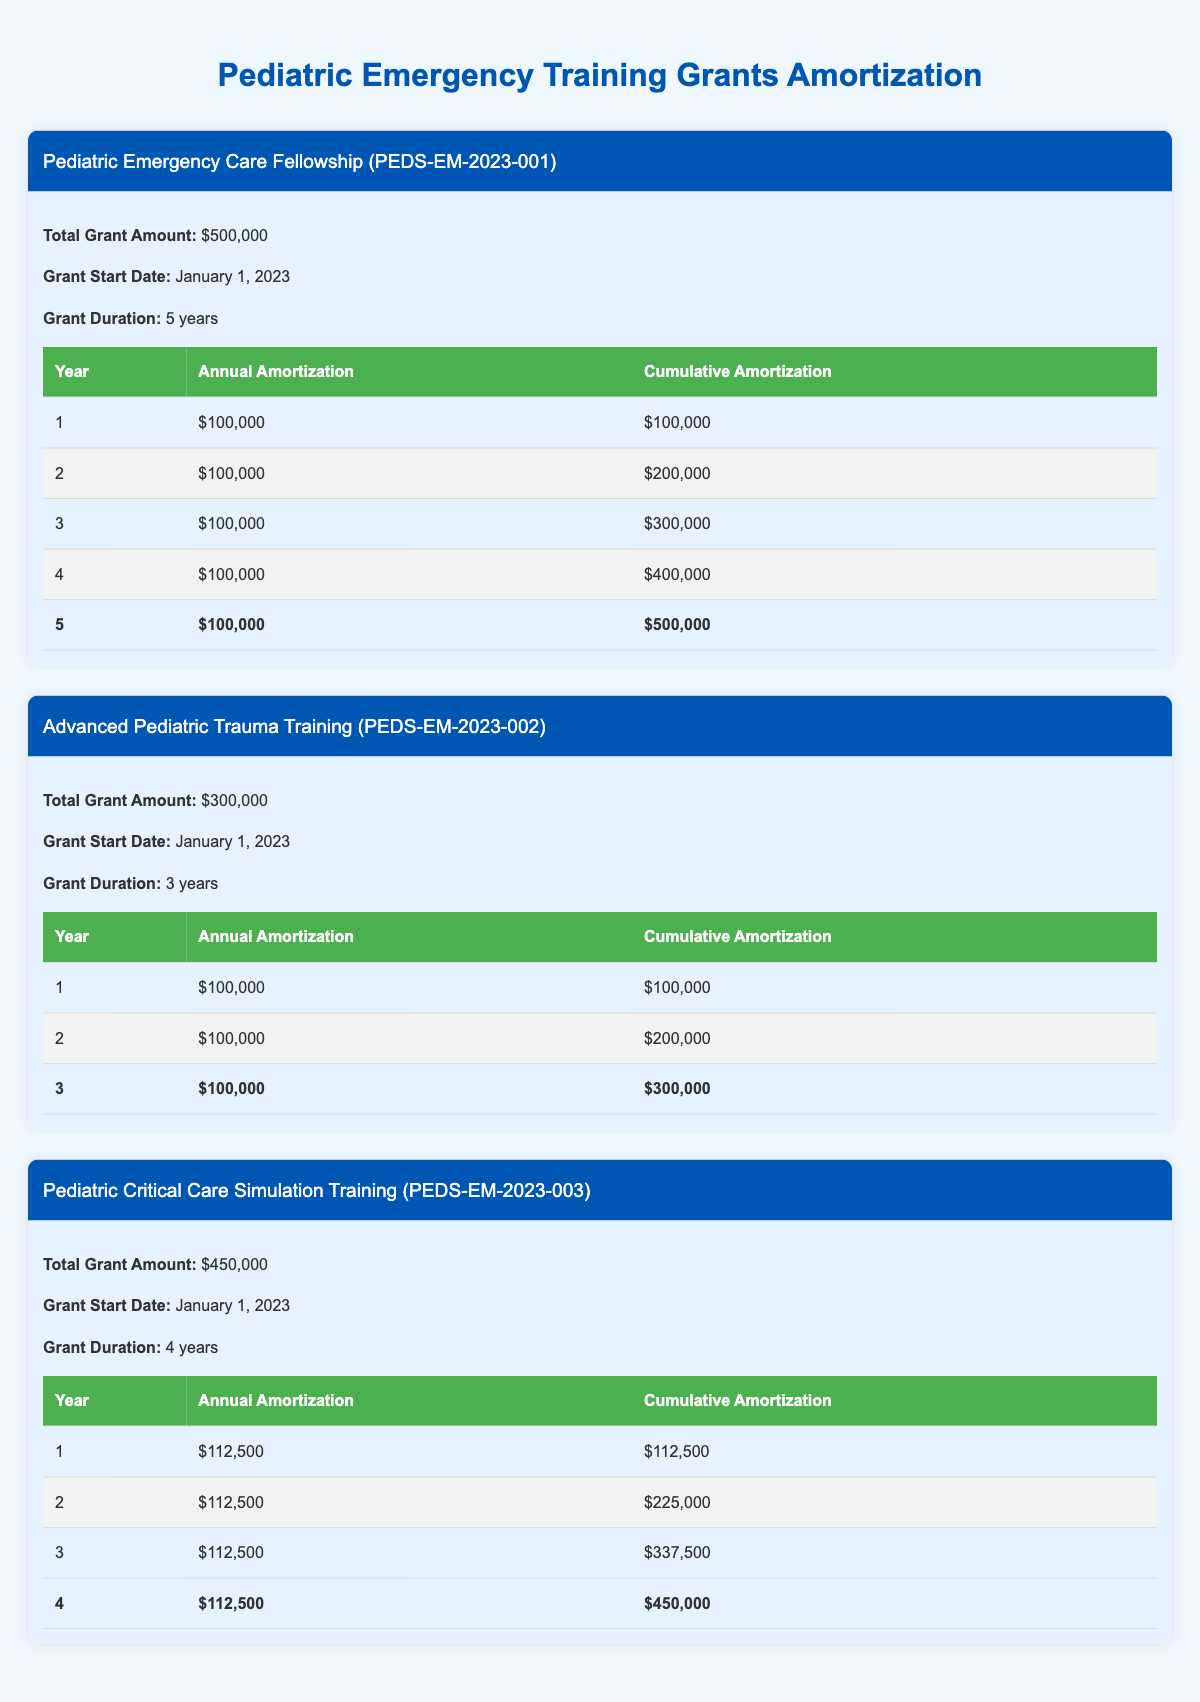What's the total grant amount for the Pediatric Emergency Care Fellowship? The total grant amount for the Pediatric Emergency Care Fellowship is listed directly in the grant details section under Total Grant Amount.
Answer: 500,000 What is the annual amortization amount for the second year of the Advanced Pediatric Trauma Training grant? The annual amortization amount for the second year of the Advanced Pediatric Trauma Training grant is specified in the annual amortization schedule under Year 2.
Answer: 100,000 How much cumulative amortization is there by the end of the third year for the Pediatric Critical Care Simulation Training? The cumulative amortization by the end of the third year is found under Year 3 in the annual amortization schedule, which states the cumulative total at that point.
Answer: 337,500 Is the total grant amount for the Advanced Pediatric Trauma Training less than $400,000? To determine if the total grant amount is less than $400,000, we look at the Total Grant Amount for Advanced Pediatric Trauma Training: $300,000, which is indeed less than $400,000.
Answer: Yes What is the average annual amortization amount across all grants? To find the average, we sum the annual amortization amounts for each grant and divide by the number of grants: (100000 + 100000 + 100000 + 100000 + 112500 + 112500 + 112500 + 112500 + 100000 + 100000 + 100000) / 6 = 100000.
Answer: 100000 By which year will the Pediatric Emergency Care Fellowship have fully amortized its grant amount? The full amortization for the Pediatric Emergency Care Fellowship occurs in year 5, as indicated by the cumulative amortization reaching the total grant amount of $500,000 at that time.
Answer: Year 5 How much more total grant funding does the Pediatric Critical Care Simulation Training have compared to the Advanced Pediatric Trauma Training? The difference in total grant amounts can be calculated by subtracting the total for the Advanced Pediatric Trauma Training ($300,000) from the Pediatric Critical Care Simulation Training ($450,000): $450,000 - $300,000 = $150,000.
Answer: 150,000 What would the cumulative amortization amount be after two years for the Pediatric Critical Care Simulation Training? To find the cumulative amortization after two years, we look at Year 2 in the Pediatric Critical Care Simulation Training's amortization schedule, which shows that the cumulative total after two years is $225,000.
Answer: 225,000 